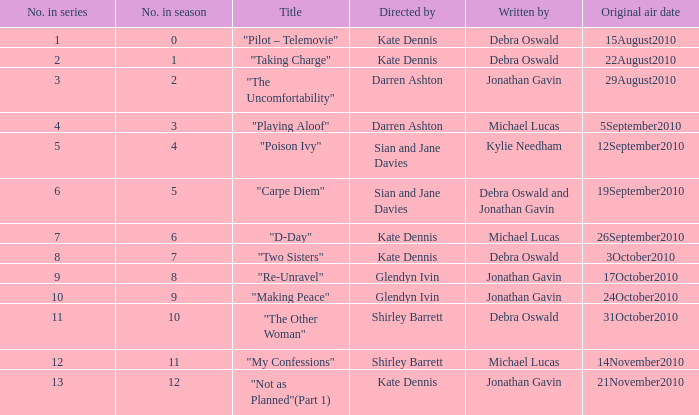Would you be able to parse every entry in this table? {'header': ['No. in series', 'No. in season', 'Title', 'Directed by', 'Written by', 'Original air date'], 'rows': [['1', '0', '"Pilot – Telemovie"', 'Kate Dennis', 'Debra Oswald', '15August2010'], ['2', '1', '"Taking Charge"', 'Kate Dennis', 'Debra Oswald', '22August2010'], ['3', '2', '"The Uncomfortability"', 'Darren Ashton', 'Jonathan Gavin', '29August2010'], ['4', '3', '"Playing Aloof"', 'Darren Ashton', 'Michael Lucas', '5September2010'], ['5', '4', '"Poison Ivy"', 'Sian and Jane Davies', 'Kylie Needham', '12September2010'], ['6', '5', '"Carpe Diem"', 'Sian and Jane Davies', 'Debra Oswald and Jonathan Gavin', '19September2010'], ['7', '6', '"D-Day"', 'Kate Dennis', 'Michael Lucas', '26September2010'], ['8', '7', '"Two Sisters"', 'Kate Dennis', 'Debra Oswald', '3October2010'], ['9', '8', '"Re-Unravel"', 'Glendyn Ivin', 'Jonathan Gavin', '17October2010'], ['10', '9', '"Making Peace"', 'Glendyn Ivin', 'Jonathan Gavin', '24October2010'], ['11', '10', '"The Other Woman"', 'Shirley Barrett', 'Debra Oswald', '31October2010'], ['12', '11', '"My Confessions"', 'Shirley Barrett', 'Michael Lucas', '14November2010'], ['13', '12', '"Not as Planned"(Part 1)', 'Kate Dennis', 'Jonathan Gavin', '21November2010']]} When did "My Confessions" first air? 14November2010. 